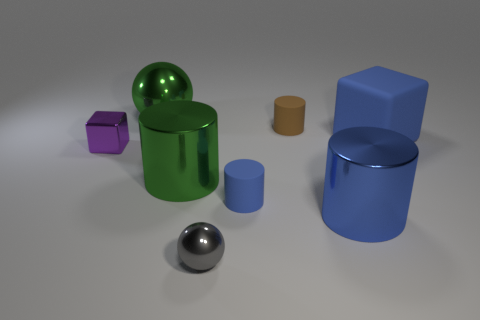Subtract all gray spheres. How many blue cylinders are left? 2 Subtract all large blue cylinders. How many cylinders are left? 3 Subtract all brown cylinders. How many cylinders are left? 3 Subtract 1 cylinders. How many cylinders are left? 3 Add 1 brown shiny cylinders. How many objects exist? 9 Subtract all yellow cylinders. Subtract all yellow cubes. How many cylinders are left? 4 Subtract 1 blue cylinders. How many objects are left? 7 Subtract all small gray matte cylinders. Subtract all cubes. How many objects are left? 6 Add 2 blue things. How many blue things are left? 5 Add 6 balls. How many balls exist? 8 